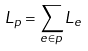<formula> <loc_0><loc_0><loc_500><loc_500>L _ { p } = \sum _ { e \in p } L _ { e }</formula> 